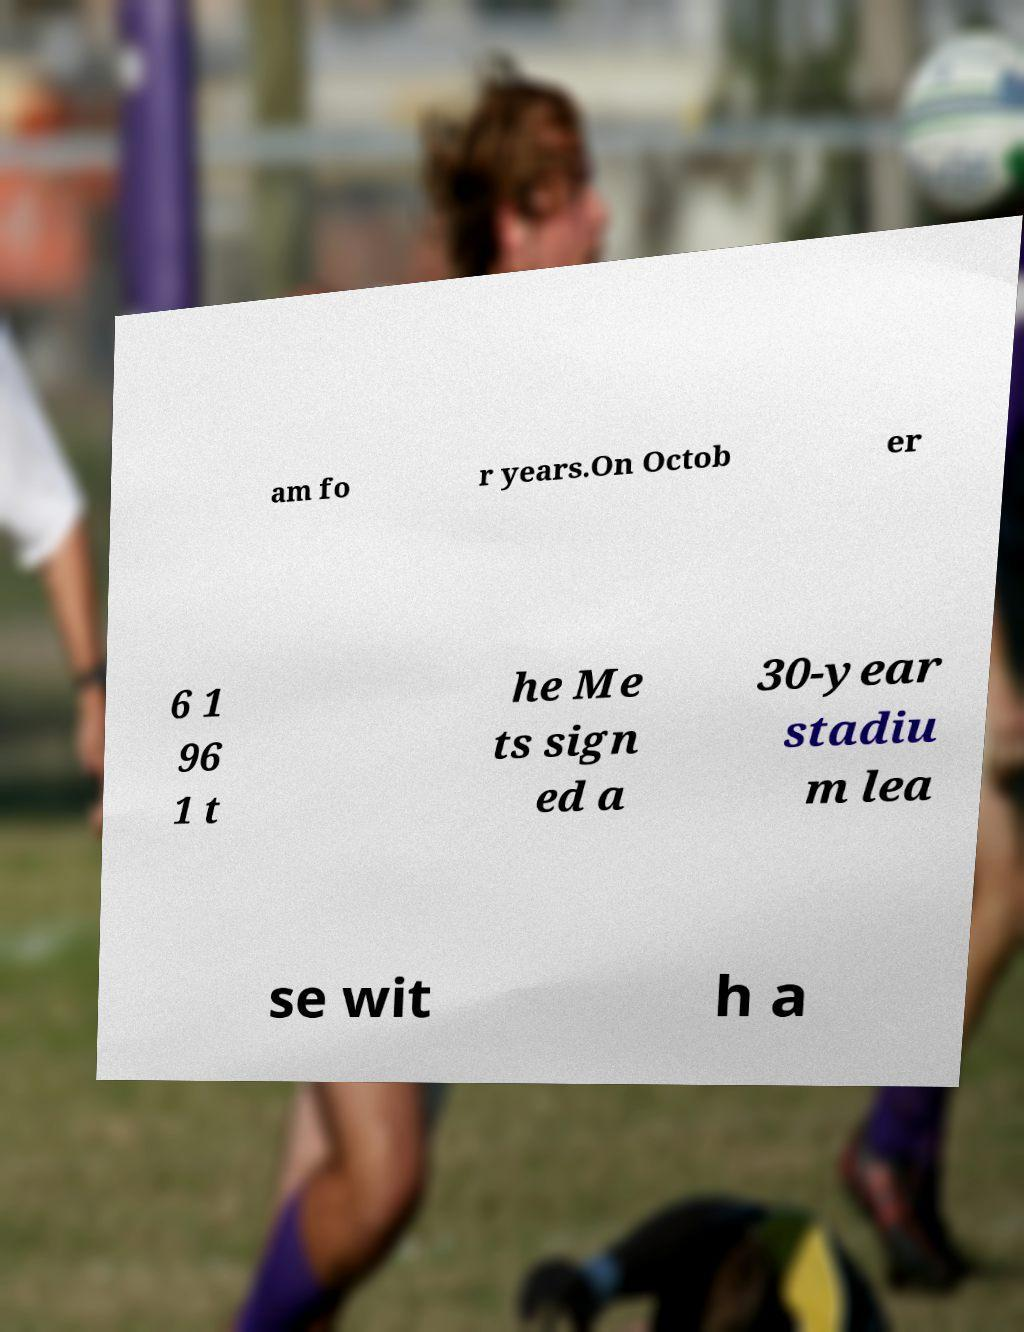I need the written content from this picture converted into text. Can you do that? am fo r years.On Octob er 6 1 96 1 t he Me ts sign ed a 30-year stadiu m lea se wit h a 